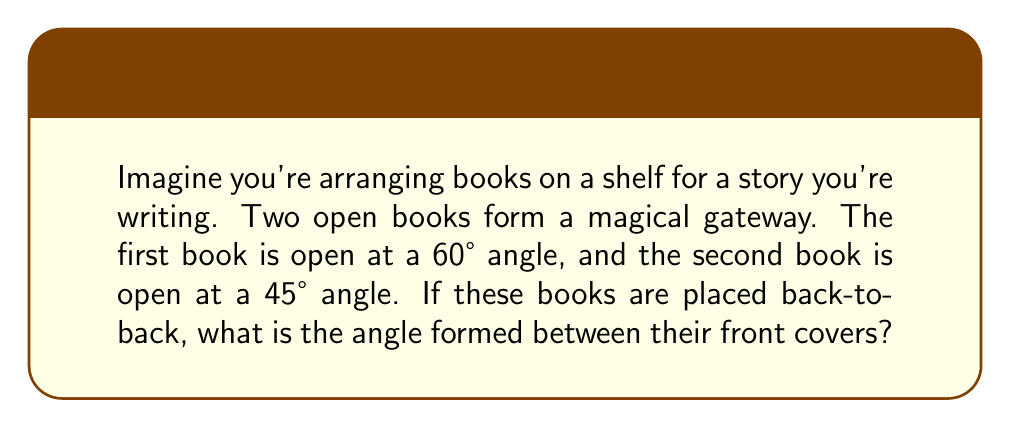Give your solution to this math problem. Let's approach this step-by-step:

1. Visualize the problem:
   [asy]
   import geometry;
   
   size(200);
   
   pair A = (0,0), B = (2,3.46), C = (4,0), D = (5.83,-1.41);
   
   draw(A--B--C--D);
   draw(A--C,dashed);
   
   label("60°", (1,0.5));
   label("45°", (3,0.5));
   label("x°", (2.5,-1));
   
   [/asy]

2. Understand the given information:
   - The first book is open at a 60° angle
   - The second book is open at a 45° angle

3. Recall that a straight line forms a 180° angle

4. For the first book:
   - The angle between the front cover and the straight line is: $180° - 60° = 120°$

5. For the second book:
   - The angle between the front cover and the straight line is: $180° - 45° = 135°$

6. The angle we're looking for (let's call it $x$) is the sum of these two angles:
   $x = 120° + 135°$

7. Calculate the final answer:
   $x = 120° + 135° = 255°$

Therefore, the angle formed between the front covers of the two books is 255°.
Answer: 255° 